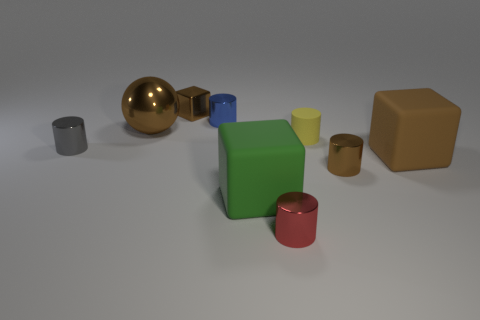What color is the cylinder on the left side of the tiny cylinder behind the large brown object that is behind the tiny yellow object?
Offer a terse response. Gray. Is there any other thing that has the same material as the yellow cylinder?
Offer a terse response. Yes. Is the shape of the large matte thing that is behind the green cube the same as  the gray metallic object?
Offer a terse response. No. What is the large sphere made of?
Keep it short and to the point. Metal. What is the shape of the tiny brown object that is in front of the small brown thing behind the brown cube in front of the yellow matte cylinder?
Your response must be concise. Cylinder. How many other objects are the same shape as the blue metal object?
Give a very brief answer. 4. There is a metal sphere; does it have the same color as the block behind the big brown matte object?
Your answer should be very brief. Yes. What number of shiny objects are there?
Offer a very short reply. 6. What number of things are big gray blocks or shiny cylinders?
Your answer should be compact. 4. What is the size of the ball that is the same color as the metallic cube?
Make the answer very short. Large. 